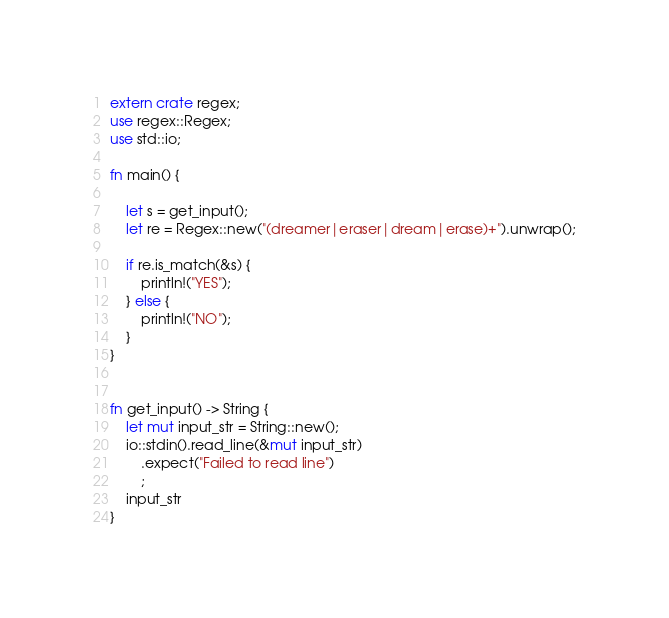Convert code to text. <code><loc_0><loc_0><loc_500><loc_500><_Rust_>extern crate regex;
use regex::Regex;
use std::io;

fn main() {

    let s = get_input();
    let re = Regex::new("(dreamer|eraser|dream|erase)+").unwrap();

    if re.is_match(&s) {
        println!("YES");
    } else {
        println!("NO");
    }
}


fn get_input() -> String {
    let mut input_str = String::new();
    io::stdin().read_line(&mut input_str)
        .expect("Failed to read line")
        ;
    input_str
}
</code> 